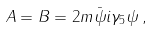<formula> <loc_0><loc_0><loc_500><loc_500>A = B = 2 m \bar { \psi } i \gamma _ { 5 } \psi \, ,</formula> 